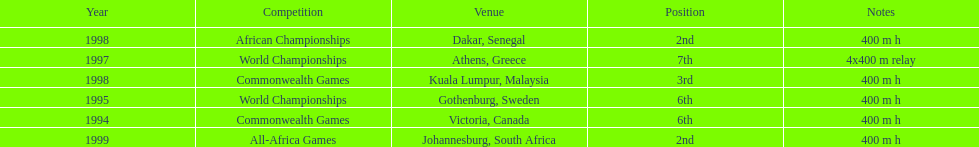What venue came before gothenburg, sweden? Victoria, Canada. 